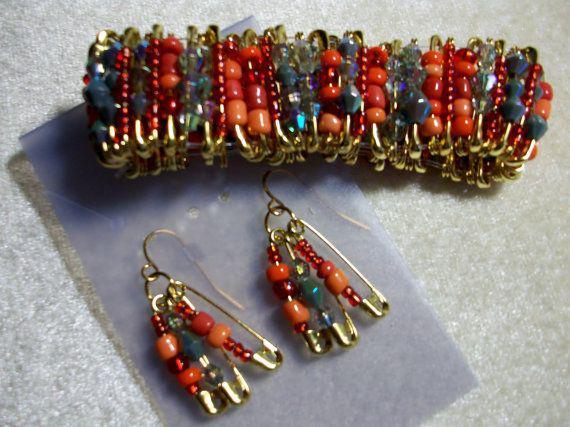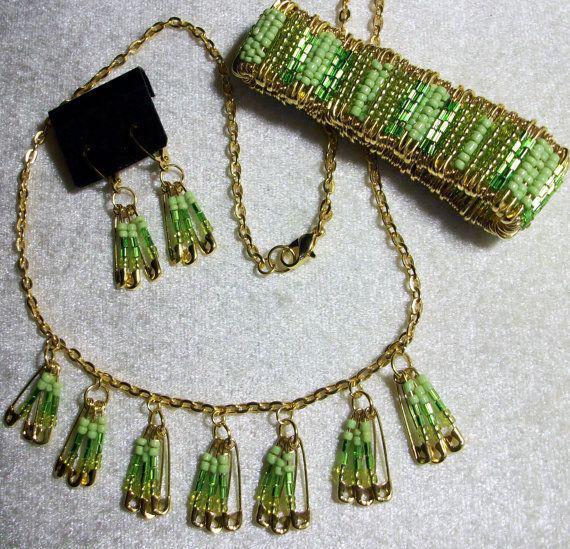The first image is the image on the left, the second image is the image on the right. Evaluate the accuracy of this statement regarding the images: "One image shows a safety pin necklace on a black display, and the other image shows a bracelet made with silver safety pins.". Is it true? Answer yes or no. No. The first image is the image on the left, the second image is the image on the right. For the images shown, is this caption "A bracelet is lying on a surface in each of the images." true? Answer yes or no. Yes. 